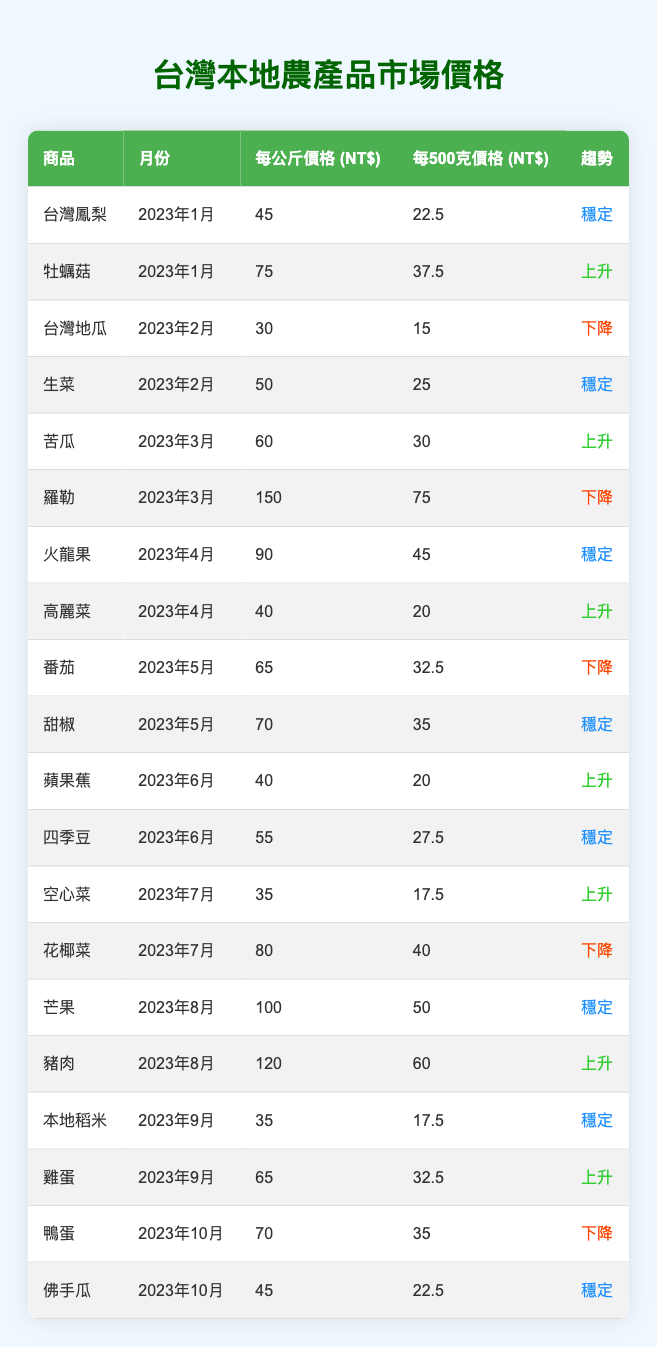What was the price of Taiwanese Pineapple in January 2023? In the table, the row for Taiwanese Pineapple lists its price as 45 NT$ per kilogram for January 2023.
Answer: 45 NT$ What is the trend for Oyster Mushrooms in January 2023? In the table, the trend for Oyster Mushrooms in January 2023 is labeled as "Increasing."
Answer: Increasing Which product had the highest price per kilogram in March 2023? Looking at the rows for March 2023: Bitter Melon is priced at 60 NT$, and Basil at 150 NT$. Basil has the highest price per kilogram.
Answer: Basil How many products showed a decreasing price trend in the first half of 2023? The first half of 2023 shows two products with a decreasing trend: Taiwanese Sweet Potato in February and Basil in March. Thus, there are two products.
Answer: 2 What was the average price per kilogram for products in April 2023? For April 2023, Dragon Fruit is 90 NT$ and Cabbage is 40 NT$. The total price is 130 NT$, and since there are 2 products, the average is 130 NT$ / 2 = 65 NT$.
Answer: 65 NT$ Is the price of Eggs higher in September 2023 than that of Local Rice? The price of Eggs in September 2023 is 65 NT$, while Local Rice is 35 NT$. Since 65 NT$ is greater than 35 NT$, the statement is true.
Answer: Yes Which month had the highest price for Mangoes and what was the price? The highest price for Mangoes occurred in August 2023 at 100 NT$ per kilogram, as noted in the table.
Answer: 100 NT$ Did any product show a stable trend over the entirety of July, August, and September 2023? In July, both Water Spinach and Cauliflower have trends listed; only Water Spinach shows "Increasing." August indicates stable for Mangoes but not for the whole period. September shows stable for Local Rice and increasing for Eggs. Hence, no product shows stable across all three months.
Answer: No What is the total price for all products listed in June 2023? The products in June 2023 are Apple Bananas (40 NT$) and Green Beans (55 NT$). The total is 40 + 55 = 95 NT$ for June 2023.
Answer: 95 NT$ Which product had the lowest price per kilogram in October 2023? In October 2023, Duck Eggs are priced at 70 NT$ and Chayote at 45 NT$. Chayote has the lowest price.
Answer: Chayote 